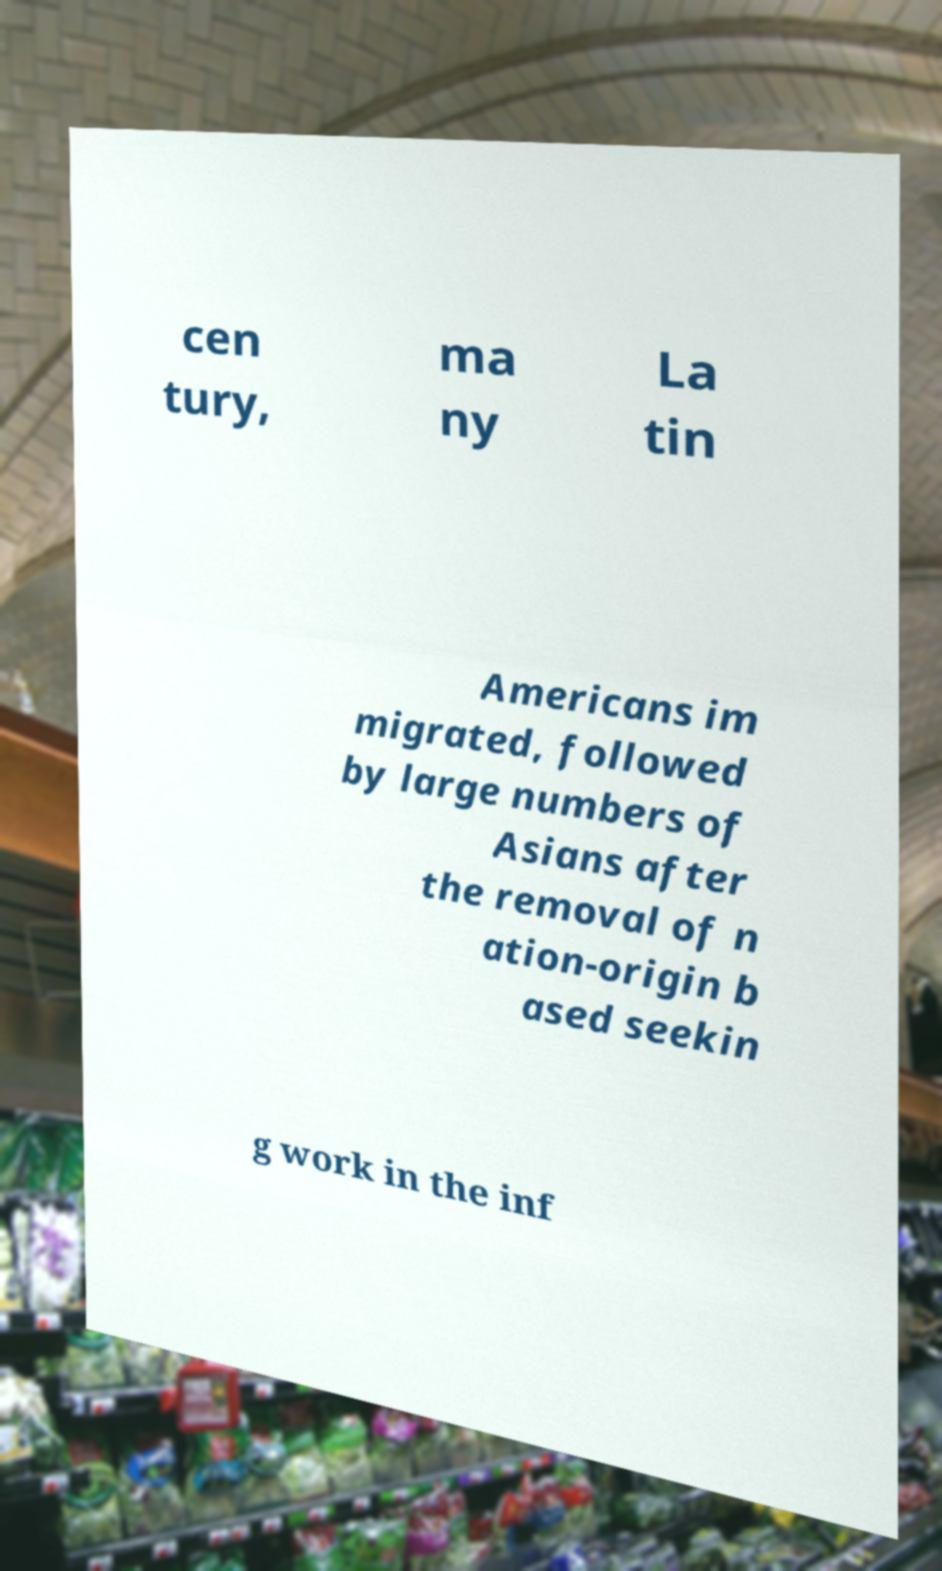Please read and relay the text visible in this image. What does it say? cen tury, ma ny La tin Americans im migrated, followed by large numbers of Asians after the removal of n ation-origin b ased seekin g work in the inf 